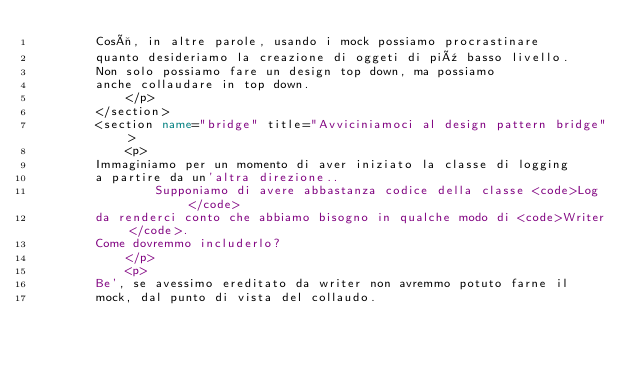Convert code to text. <code><loc_0><loc_0><loc_500><loc_500><_XML_>				Così, in altre parole, usando i mock possiamo procrastinare
				quanto desideriamo la creazione di oggeti di più basso livello.
				Non solo possiamo fare un design top down, ma possiamo
				anche collaudare in top down.
            </p>
        </section>
        <section name="bridge" title="Avviciniamoci al design pattern bridge">
            <p>
				Immaginiamo per un momento di aver iniziato la classe di logging
				a partire da un'altra direzione..
                Supponiamo di avere abbastanza codice della classe <code>Log</code>
				da renderci conto che abbiamo bisogno in qualche modo di <code>Writer</code>.
				Come dovremmo includerlo?
            </p>
            <p>
				Be', se avessimo ereditato da writer non avremmo potuto farne il
				mock, dal punto di vista del collaudo.</code> 